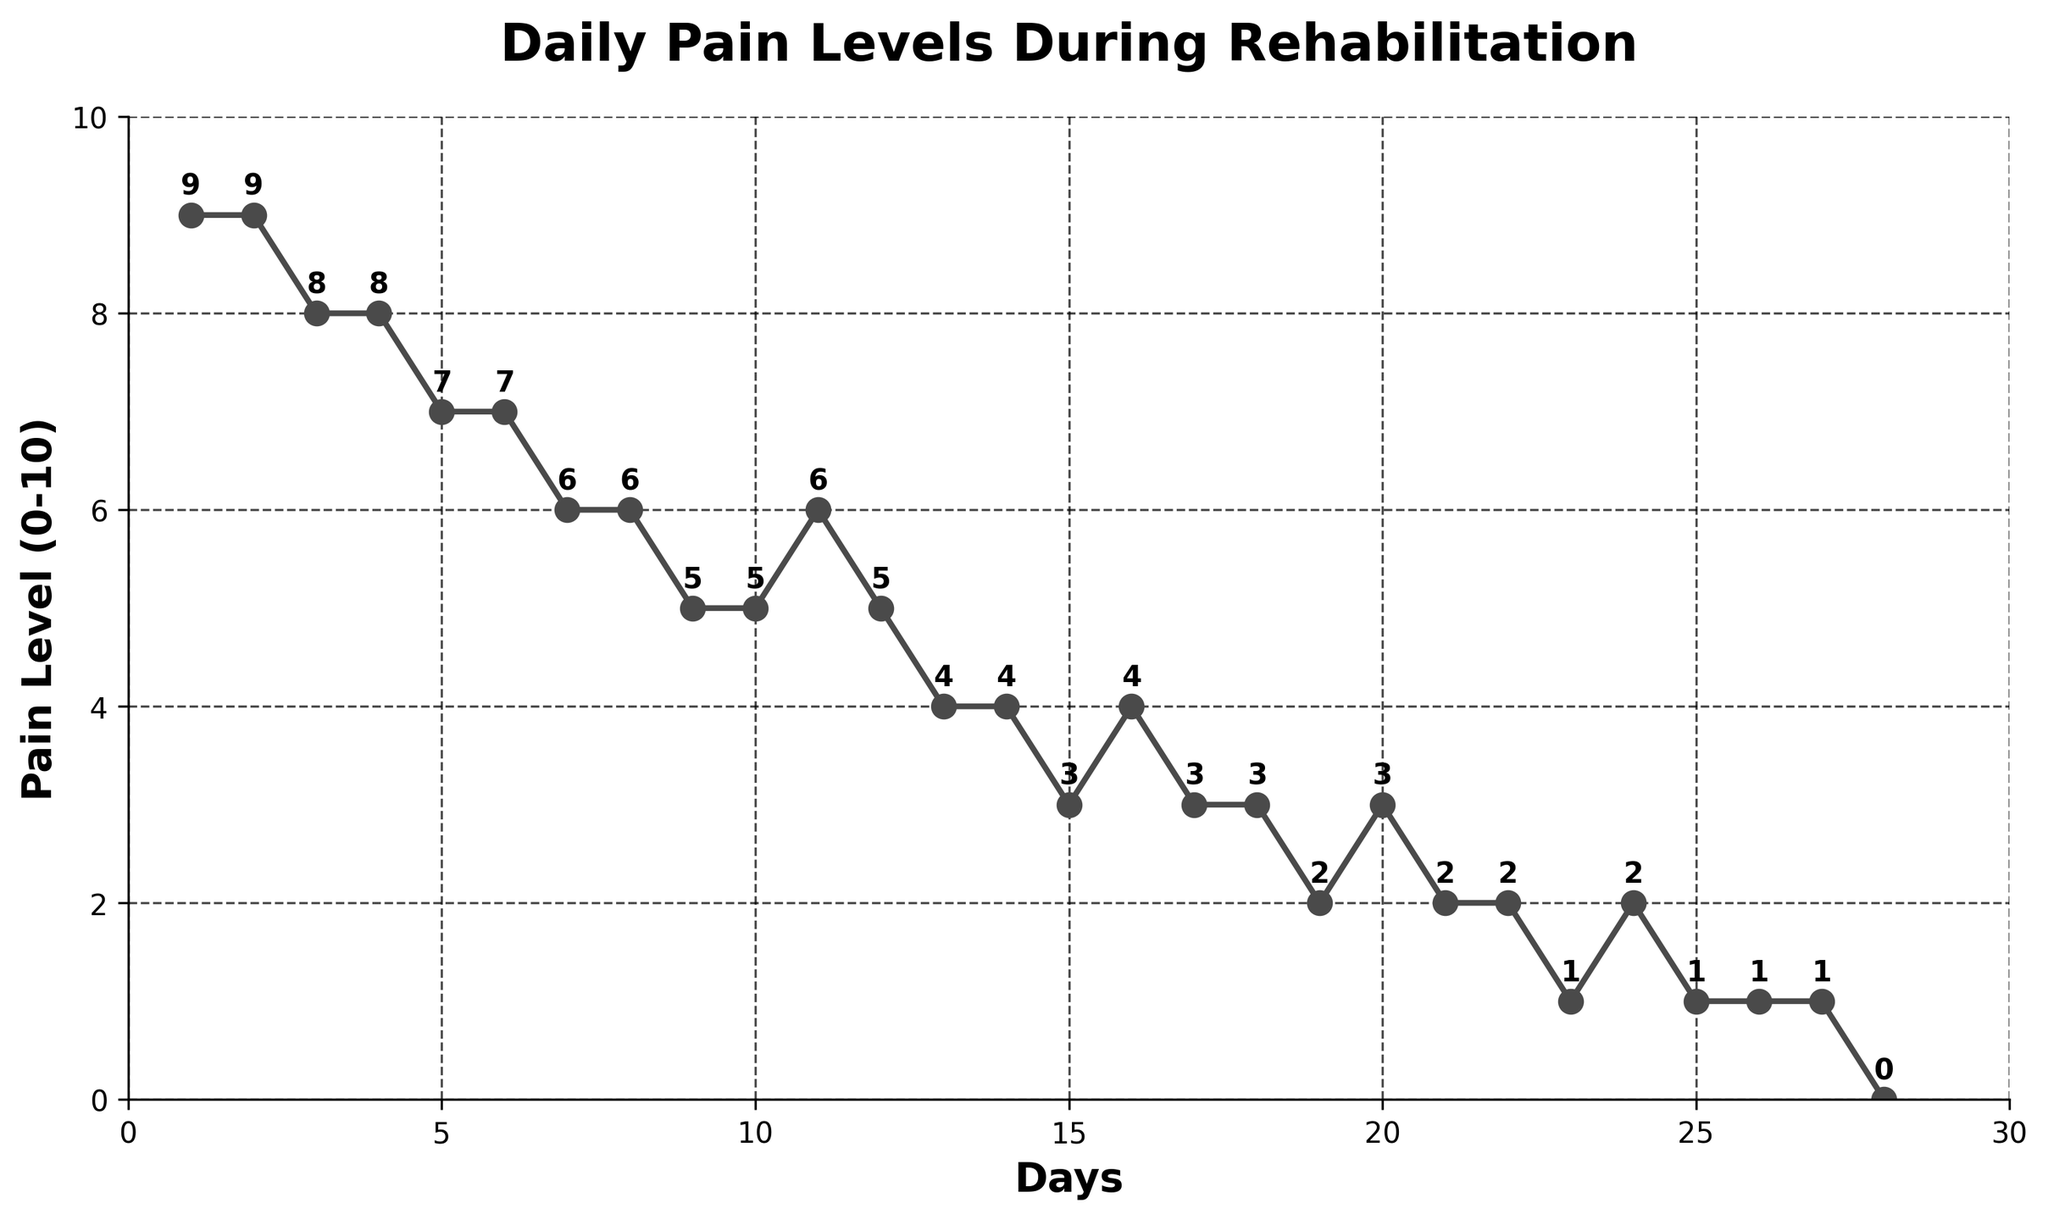What was the pain level on Day 10? The number corresponding to Day 10 on the horizontal axis is aligned with the point at Pain Level 5 on the vertical axis.
Answer: 5 Which day had the highest pain level? By looking at the line chart, the highest pain level is at Day 1 and Day 2 with the pain level of 9.
Answer: Day 1 and Day 2 By how much did the pain level decrease from Day 1 to Day 5? The pain level on Day 1 was 9 and on Day 5 it was 7. Subtracting these gives 9 - 7 = 2.
Answer: 2 What is the average pain level from Day 1 to Day 7? Summing up the pain levels from Day 1 to Day 7 is 9 + 9 + 8 + 8 + 7 + 7 + 6 = 54. There are 7 days, so the average is 54 / 7 ≈ 7.71.
Answer: 7.71 Which day marked the first significant drop in pain level? (Consider a drop of 1 or more as significant) From Day 2 to Day 3, the pain level drops from 9 to 8, which is the first drop of 1 or more.
Answer: Day 3 Is there any day where the pain level increased compared to the previous day? Yes, from Day 10 to Day 11, the pain level increases from 5 to 6.
Answer: Yes What is the median pain level from Day 1 to Day 28? The list of pain levels from Day 1 to Day 28 is [9, 9, 8, 8, 7, 7, 6, 6, 5, 5, 6, 5, 4, 4, 3, 4, 3, 3, 2, 3, 2, 2, 1, 2, 1, 1, 1, 0]. To find the median, arrange these pain levels in ascending order: [0, 1, 1, 1, 1, 2, 2, 2, 2, 3, 3, 3, 4, 4, 4, 5, 5, 5, 5, 6, 6, 6, 7, 7, 8, 8, 9, 9]. The middle values (14th and 15th) are both 4, so the median is 4.
Answer: 4 Compare the pain level on Day 13 to Day 23. Which is higher? On Day 13, the pain level is 4 and on Day 23, it is 1. Therefore, the pain level on Day 13 is higher.
Answer: Day 13 